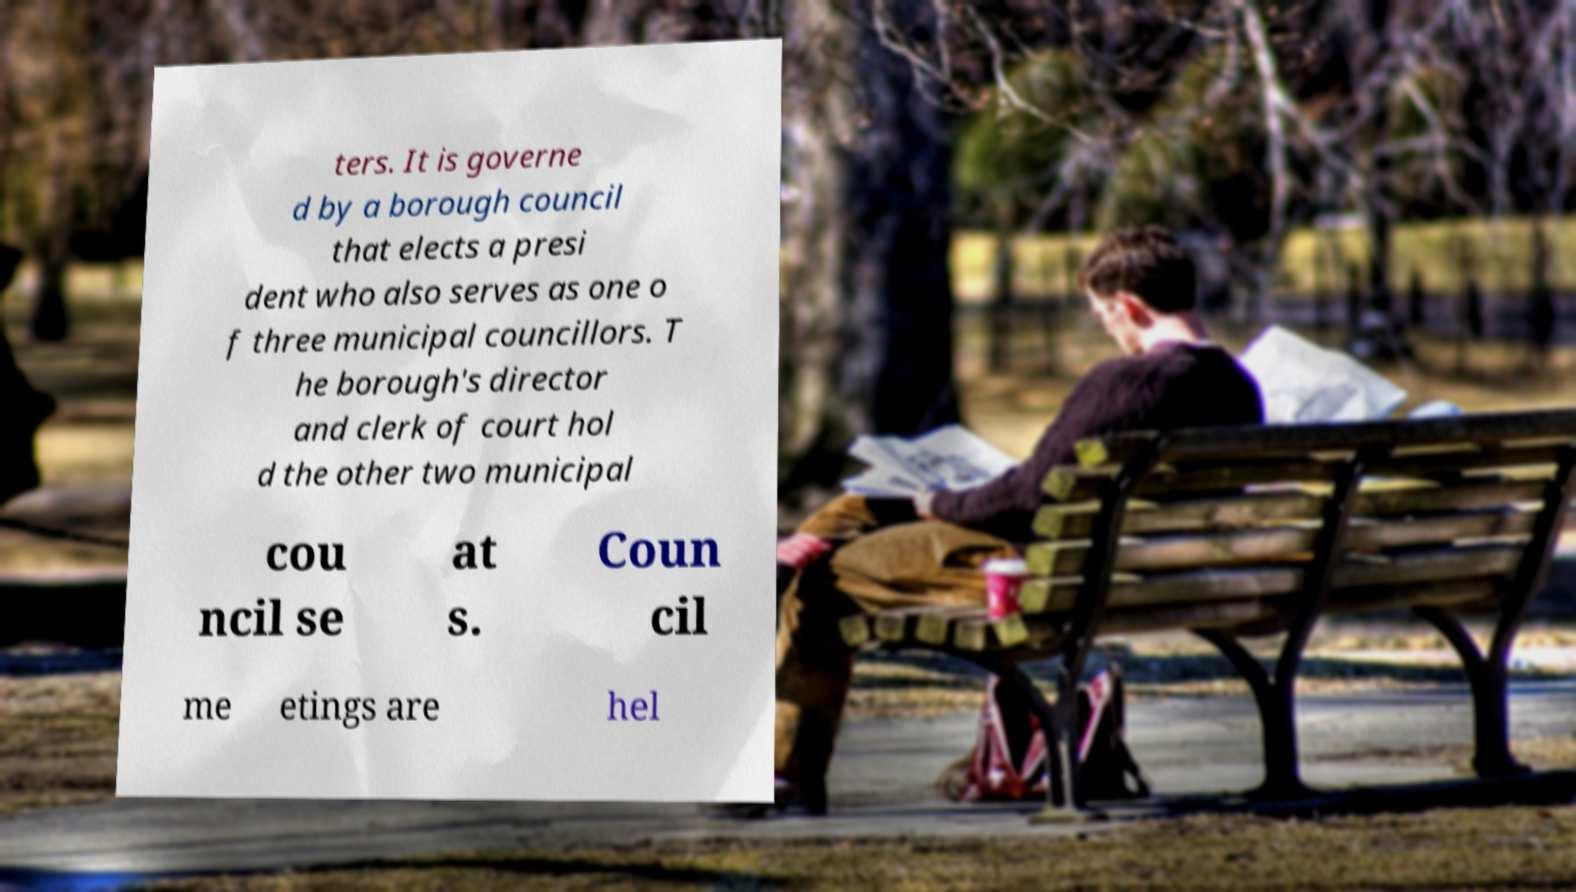Can you read and provide the text displayed in the image?This photo seems to have some interesting text. Can you extract and type it out for me? ters. It is governe d by a borough council that elects a presi dent who also serves as one o f three municipal councillors. T he borough's director and clerk of court hol d the other two municipal cou ncil se at s. Coun cil me etings are hel 